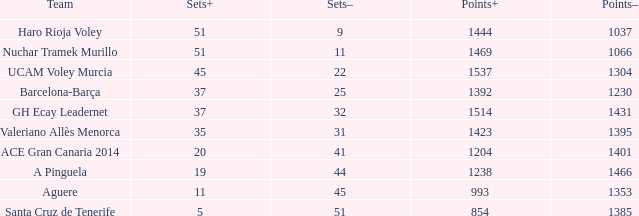What is the highest Sets+ number for Valeriano Allès Menorca when the Sets- number was larger than 31? None. 